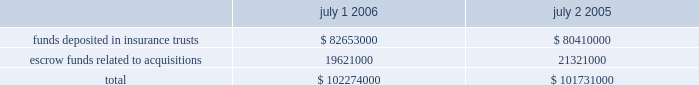Restricted cash sysco is required by its insurers to collateralize a part of the self-insured portion of its workers 2019 compensation and liability claims .
Sysco has chosen to satisfy these collateral requirements by depositing funds in insurance trusts or by issuing letters of credit .
In addition , for certain acquisitions , sysco has placed funds into escrow to be disbursed to the sellers in the event that specified operating results are attained or contingencies are resolved .
Escrowed funds related to certain acquisitions in the amount of $ 1700000 were released during fiscal 2006 , which included $ 800000 that was disbursed to sellers .
A summary of restricted cash balances appears below: .
Funds deposited in insurance trusts************************************** $ 82653000 $ 80410000 escrow funds related to acquisitions ************************************* 19621000 21321000 total************************************************************* $ 102274000 $ 101731000 7 .
Derivative financial instruments sysco manages its debt portfolio by targeting an overall desired position of fixed and floating rates and may employ interest rate swaps from time to time to achieve this goal .
The company does not use derivative financial instruments for trading or speculative purposes .
During fiscal years 2003 , 2004 and 2005 , the company entered into various interest rate swap agreements designated as fair value hedges of the related debt .
The terms of these swap agreements and the hedged items were such that the hedges were considered perfectly effective against changes in the fair value of the debt due to changes in the benchmark interest rates over their terms .
As a result , the shortcut method provided by sfas no .
133 , 2018 2018accounting for derivative instruments and hedging activities , 2019 2019 was applied and there was no need to periodically reassess the effectiveness of the hedges during the terms of the swaps .
Interest expense on the debt was adjusted to include payments made or received under the hedge agreements .
The fair value of the swaps was carried as an asset or a liability on the consolidated balance sheet and the carrying value of the hedged debt was adjusted accordingly .
There were no fair value hedges outstanding as of july 1 , 2006 or july 2 , 2005 .
The amount received upon termination of fair value hedge swap agreements was $ 5316000 and $ 1305000 in fiscal years 2005 and 2004 , respectively .
There were no terminations of fair value hedge swap agreements in fiscal 2006 .
The amount received upon termination of swap agreements is reflected as an increase in the carrying value of the related debt to reflect its fair value at termination .
This increase in the carrying value of the debt is amortized as a reduction of interest expense over the remaining term of the debt .
In march 2005 , sysco entered into a forward-starting interest rate swap with a notional amount of $ 350000000 .
In accordance with sfas no .
133 , the company designated this derivative as a cash flow hedge of the variability in the cash outflows of interest payments on $ 350000000 of the september 2005 forecasted debt issuance due to changes in the benchmark interest rate .
The fair value of the swap as of july 2 , 2005 was ( $ 32584000 ) , which is reflected in accrued expenses on the consolidated balance sheet , with the corresponding amount reflected as a loss , net of tax , in other comprehensive income ( loss ) .
In september 2005 , in conjunction with the issuance of the 5.375% ( 5.375 % ) senior notes , sysco settled the $ 350000000 notional amount forward-starting interest rate swap .
Upon settlement , sysco paid cash of $ 21196000 , which represented the fair value of the swap agreement at the time of settlement .
This amount is being amortized as interest expense over the 30-year term of the debt , and the unamortized balance is reflected as a loss , net of tax , in other comprehensive income ( loss ) .
In the normal course of business , sysco enters into forward purchase agreements for the procurement of fuel , electricity and product commodities related to sysco 2019s business .
Certain of these agreements meet the definition of a derivative and qualify for the normal purchase and sale exemption under relevant accounting literature .
The company has elected to use this exemption for these agreements and thus they are not recorded at fair value .
%%transmsg*** transmitting job : h39408 pcn : 046000000 *** %%pcmsg|44 |00010|yes|no|09/06/2006 17:22|0|1|page is valid , no graphics -- color : n| .
What percentage of restricted cash as of july 1 , 2006 was in funds deposited in insurance trusts? 
Computations: (82653000 / 102274000)
Answer: 0.80815. 